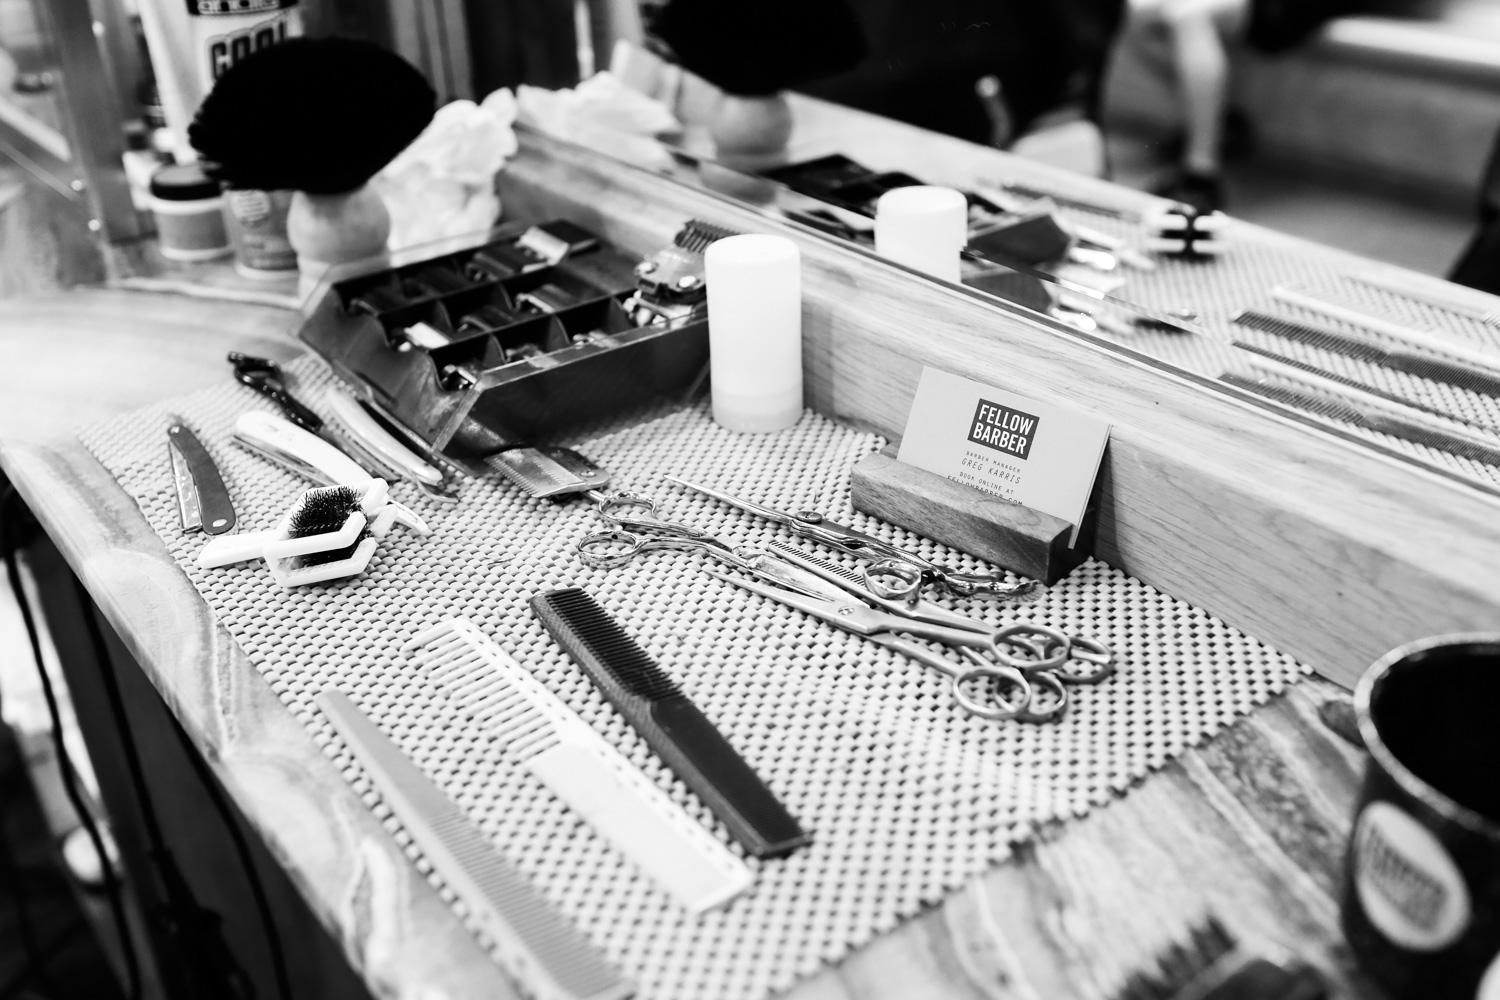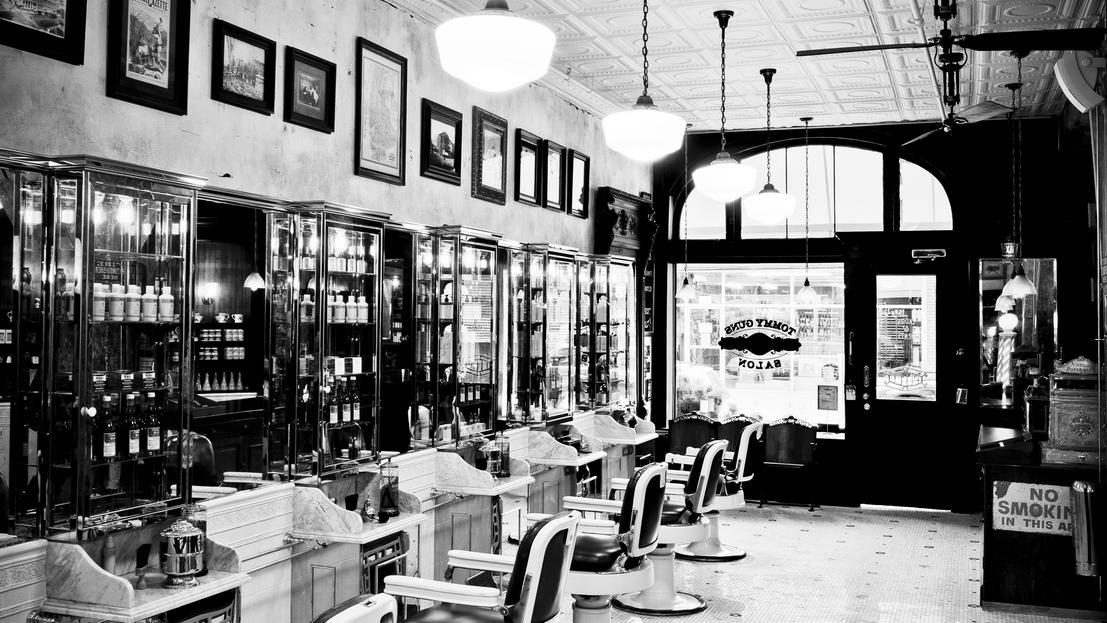The first image is the image on the left, the second image is the image on the right. For the images displayed, is the sentence "An image shows a display of barber tools, including scissors." factually correct? Answer yes or no. Yes. The first image is the image on the left, the second image is the image on the right. Considering the images on both sides, is "A barbershop image shows a man sitting in a barber chair with other people in the shop, and large windows in the background." valid? Answer yes or no. No. 